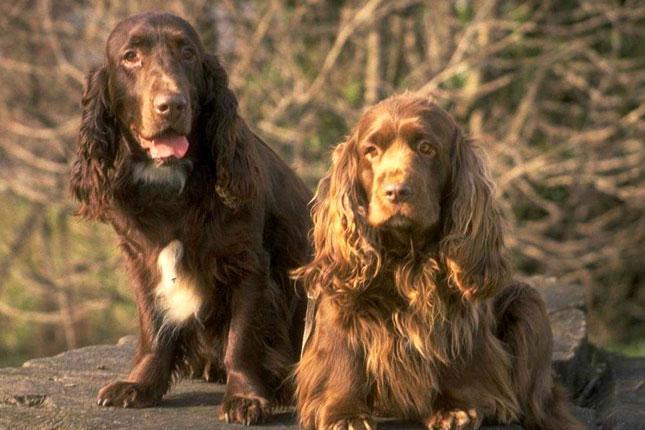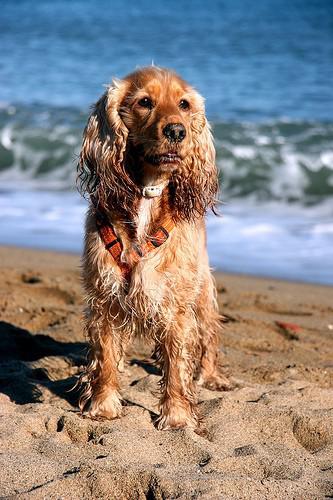The first image is the image on the left, the second image is the image on the right. For the images displayed, is the sentence "An image contains exactly two dogs." factually correct? Answer yes or no. Yes. The first image is the image on the left, the second image is the image on the right. Considering the images on both sides, is "One image contains one forward-facing orange spaniel with wet fur, posed in front of the ocean." valid? Answer yes or no. Yes. 